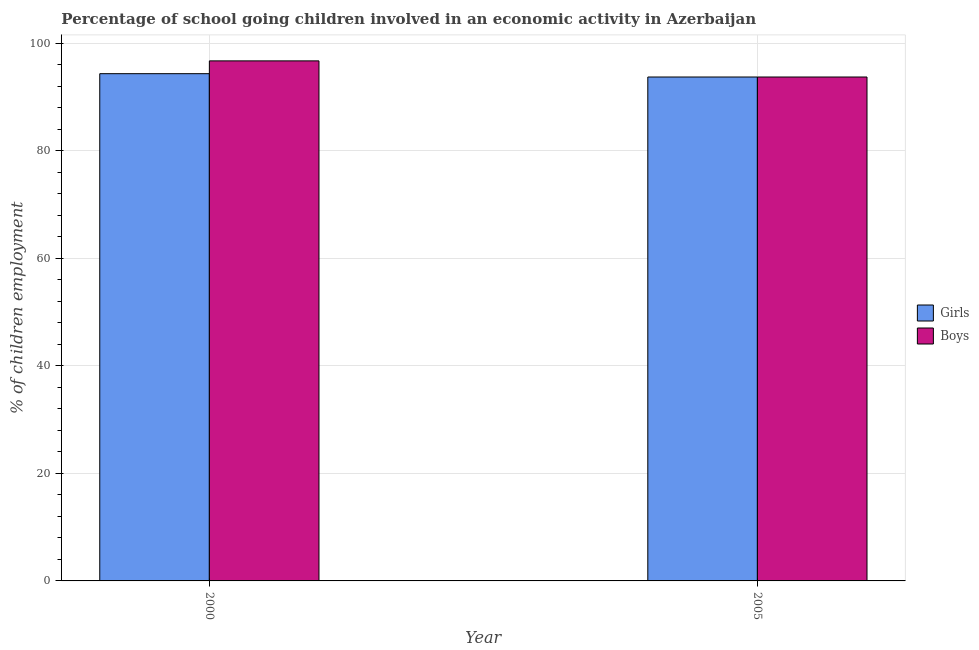How many different coloured bars are there?
Ensure brevity in your answer.  2. Are the number of bars per tick equal to the number of legend labels?
Give a very brief answer. Yes. Are the number of bars on each tick of the X-axis equal?
Give a very brief answer. Yes. How many bars are there on the 1st tick from the left?
Your response must be concise. 2. What is the label of the 2nd group of bars from the left?
Offer a very short reply. 2005. In how many cases, is the number of bars for a given year not equal to the number of legend labels?
Provide a short and direct response. 0. What is the percentage of school going boys in 2000?
Provide a succinct answer. 96.7. Across all years, what is the maximum percentage of school going boys?
Provide a short and direct response. 96.7. Across all years, what is the minimum percentage of school going girls?
Keep it short and to the point. 93.7. In which year was the percentage of school going girls maximum?
Ensure brevity in your answer.  2000. What is the total percentage of school going boys in the graph?
Offer a very short reply. 190.4. What is the difference between the percentage of school going boys in 2000 and that in 2005?
Give a very brief answer. 3. What is the difference between the percentage of school going girls in 2005 and the percentage of school going boys in 2000?
Your answer should be compact. -0.62. What is the average percentage of school going girls per year?
Make the answer very short. 94.01. In the year 2000, what is the difference between the percentage of school going girls and percentage of school going boys?
Keep it short and to the point. 0. What is the ratio of the percentage of school going girls in 2000 to that in 2005?
Ensure brevity in your answer.  1.01. Is the percentage of school going girls in 2000 less than that in 2005?
Provide a succinct answer. No. In how many years, is the percentage of school going girls greater than the average percentage of school going girls taken over all years?
Keep it short and to the point. 1. What does the 2nd bar from the left in 2005 represents?
Make the answer very short. Boys. What does the 2nd bar from the right in 2000 represents?
Provide a short and direct response. Girls. Are all the bars in the graph horizontal?
Ensure brevity in your answer.  No. Does the graph contain any zero values?
Give a very brief answer. No. Does the graph contain grids?
Keep it short and to the point. Yes. How are the legend labels stacked?
Provide a short and direct response. Vertical. What is the title of the graph?
Provide a succinct answer. Percentage of school going children involved in an economic activity in Azerbaijan. Does "Mineral" appear as one of the legend labels in the graph?
Your answer should be compact. No. What is the label or title of the Y-axis?
Keep it short and to the point. % of children employment. What is the % of children employment in Girls in 2000?
Offer a very short reply. 94.32. What is the % of children employment in Boys in 2000?
Keep it short and to the point. 96.7. What is the % of children employment of Girls in 2005?
Your answer should be compact. 93.7. What is the % of children employment in Boys in 2005?
Give a very brief answer. 93.7. Across all years, what is the maximum % of children employment of Girls?
Your answer should be compact. 94.32. Across all years, what is the maximum % of children employment of Boys?
Make the answer very short. 96.7. Across all years, what is the minimum % of children employment of Girls?
Offer a terse response. 93.7. Across all years, what is the minimum % of children employment in Boys?
Provide a short and direct response. 93.7. What is the total % of children employment of Girls in the graph?
Give a very brief answer. 188.02. What is the total % of children employment in Boys in the graph?
Offer a terse response. 190.4. What is the difference between the % of children employment of Girls in 2000 and that in 2005?
Your response must be concise. 0.62. What is the difference between the % of children employment of Boys in 2000 and that in 2005?
Provide a short and direct response. 3. What is the difference between the % of children employment of Girls in 2000 and the % of children employment of Boys in 2005?
Your response must be concise. 0.62. What is the average % of children employment of Girls per year?
Provide a succinct answer. 94.01. What is the average % of children employment of Boys per year?
Your answer should be very brief. 95.2. In the year 2000, what is the difference between the % of children employment in Girls and % of children employment in Boys?
Make the answer very short. -2.38. In the year 2005, what is the difference between the % of children employment in Girls and % of children employment in Boys?
Make the answer very short. 0. What is the ratio of the % of children employment in Girls in 2000 to that in 2005?
Give a very brief answer. 1.01. What is the ratio of the % of children employment of Boys in 2000 to that in 2005?
Provide a succinct answer. 1.03. What is the difference between the highest and the second highest % of children employment of Girls?
Ensure brevity in your answer.  0.62. What is the difference between the highest and the second highest % of children employment of Boys?
Give a very brief answer. 3. What is the difference between the highest and the lowest % of children employment in Girls?
Offer a terse response. 0.62. What is the difference between the highest and the lowest % of children employment of Boys?
Make the answer very short. 3. 